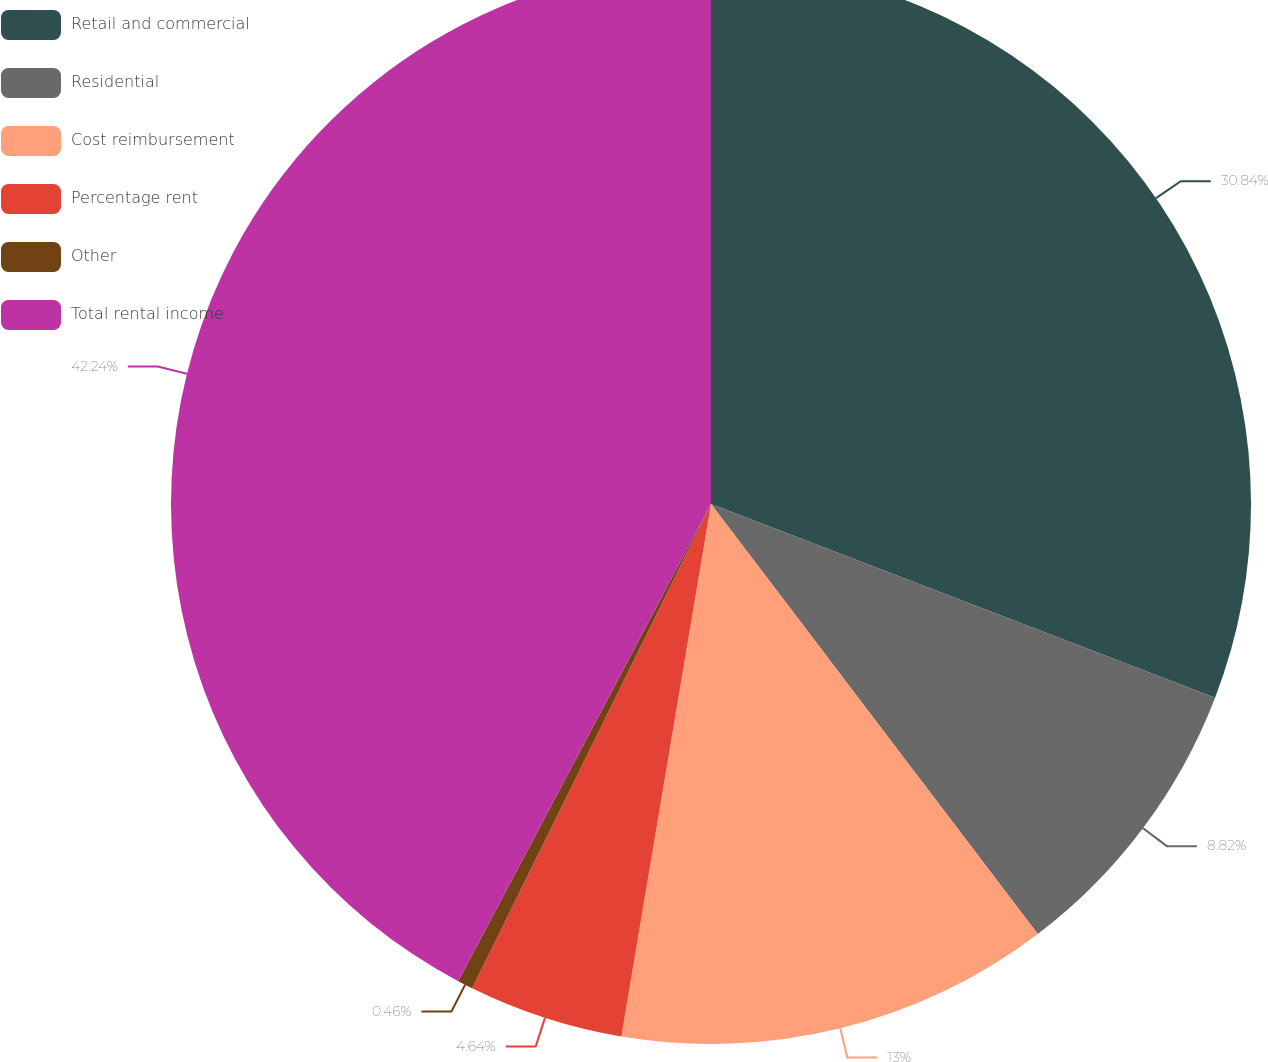Convert chart to OTSL. <chart><loc_0><loc_0><loc_500><loc_500><pie_chart><fcel>Retail and commercial<fcel>Residential<fcel>Cost reimbursement<fcel>Percentage rent<fcel>Other<fcel>Total rental income<nl><fcel>30.84%<fcel>8.82%<fcel>13.0%<fcel>4.64%<fcel>0.46%<fcel>42.25%<nl></chart> 